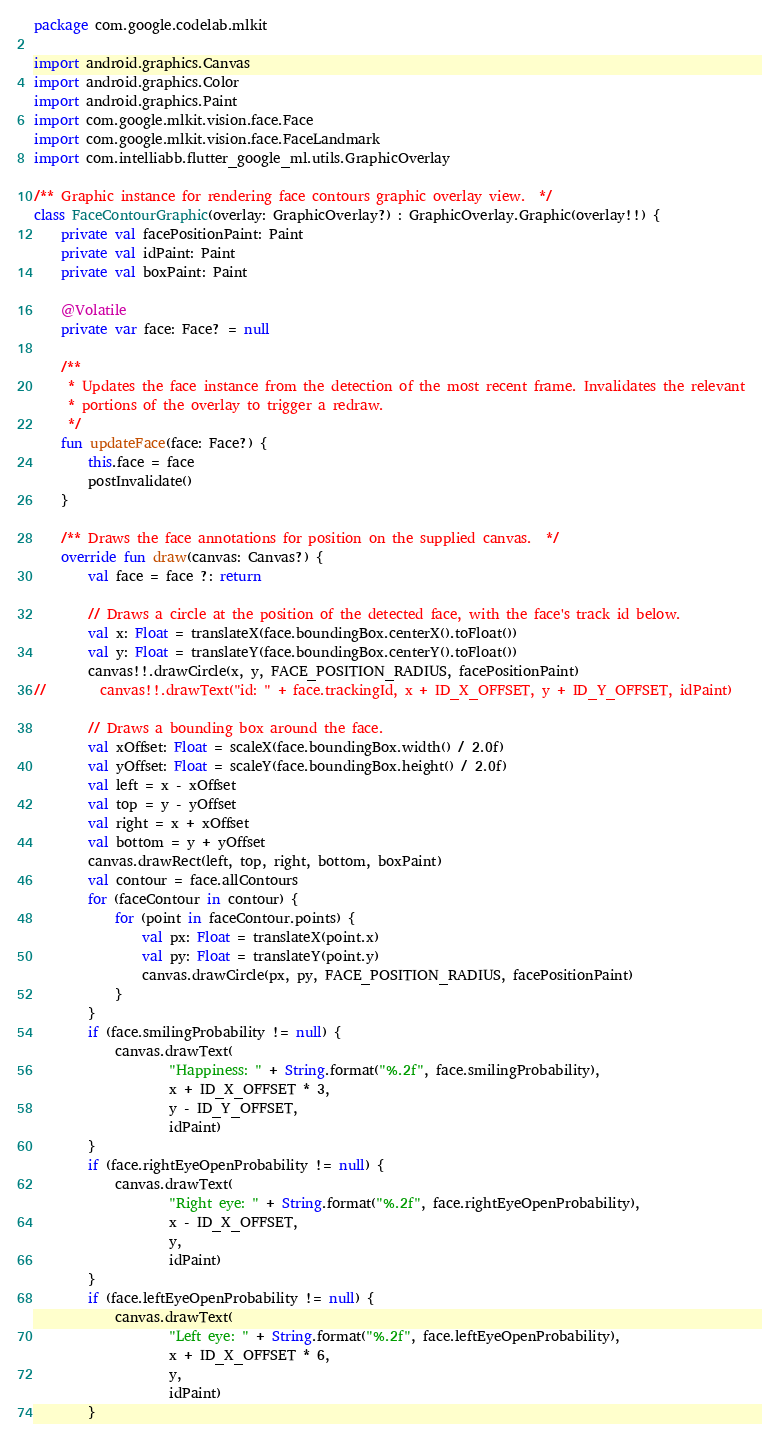<code> <loc_0><loc_0><loc_500><loc_500><_Kotlin_>package com.google.codelab.mlkit

import android.graphics.Canvas
import android.graphics.Color
import android.graphics.Paint
import com.google.mlkit.vision.face.Face
import com.google.mlkit.vision.face.FaceLandmark
import com.intelliabb.flutter_google_ml.utils.GraphicOverlay

/** Graphic instance for rendering face contours graphic overlay view.  */
class FaceContourGraphic(overlay: GraphicOverlay?) : GraphicOverlay.Graphic(overlay!!) {
    private val facePositionPaint: Paint
    private val idPaint: Paint
    private val boxPaint: Paint

    @Volatile
    private var face: Face? = null

    /**
     * Updates the face instance from the detection of the most recent frame. Invalidates the relevant
     * portions of the overlay to trigger a redraw.
     */
    fun updateFace(face: Face?) {
        this.face = face
        postInvalidate()
    }

    /** Draws the face annotations for position on the supplied canvas.  */
    override fun draw(canvas: Canvas?) {
        val face = face ?: return

        // Draws a circle at the position of the detected face, with the face's track id below.
        val x: Float = translateX(face.boundingBox.centerX().toFloat())
        val y: Float = translateY(face.boundingBox.centerY().toFloat())
        canvas!!.drawCircle(x, y, FACE_POSITION_RADIUS, facePositionPaint)
//        canvas!!.drawText("id: " + face.trackingId, x + ID_X_OFFSET, y + ID_Y_OFFSET, idPaint)

        // Draws a bounding box around the face.
        val xOffset: Float = scaleX(face.boundingBox.width() / 2.0f)
        val yOffset: Float = scaleY(face.boundingBox.height() / 2.0f)
        val left = x - xOffset
        val top = y - yOffset
        val right = x + xOffset
        val bottom = y + yOffset
        canvas.drawRect(left, top, right, bottom, boxPaint)
        val contour = face.allContours
        for (faceContour in contour) {
            for (point in faceContour.points) {
                val px: Float = translateX(point.x)
                val py: Float = translateY(point.y)
                canvas.drawCircle(px, py, FACE_POSITION_RADIUS, facePositionPaint)
            }
        }
        if (face.smilingProbability != null) {
            canvas.drawText(
                    "Happiness: " + String.format("%.2f", face.smilingProbability),
                    x + ID_X_OFFSET * 3,
                    y - ID_Y_OFFSET,
                    idPaint)
        }
        if (face.rightEyeOpenProbability != null) {
            canvas.drawText(
                    "Right eye: " + String.format("%.2f", face.rightEyeOpenProbability),
                    x - ID_X_OFFSET,
                    y,
                    idPaint)
        }
        if (face.leftEyeOpenProbability != null) {
            canvas.drawText(
                    "Left eye: " + String.format("%.2f", face.leftEyeOpenProbability),
                    x + ID_X_OFFSET * 6,
                    y,
                    idPaint)
        }</code> 